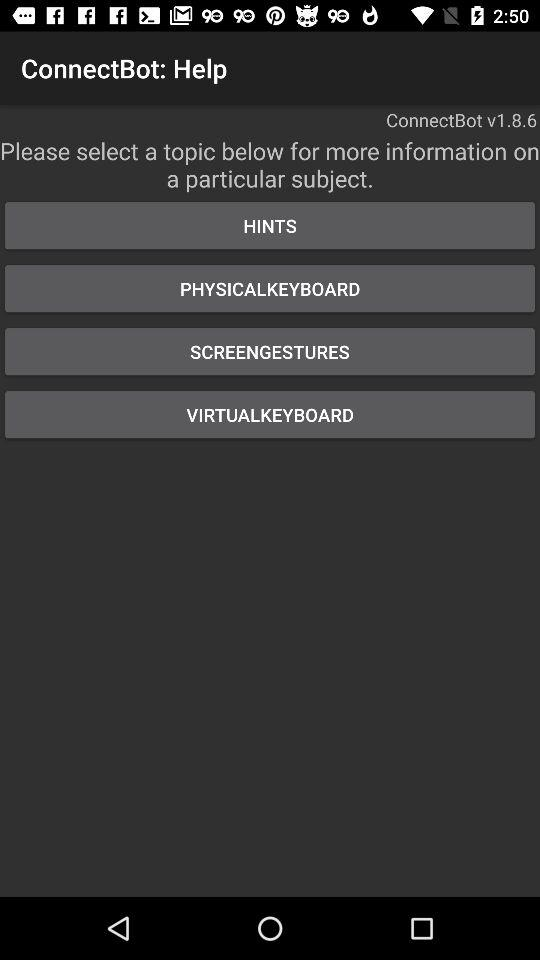How many topics are there in the help menu?
Answer the question using a single word or phrase. 4 